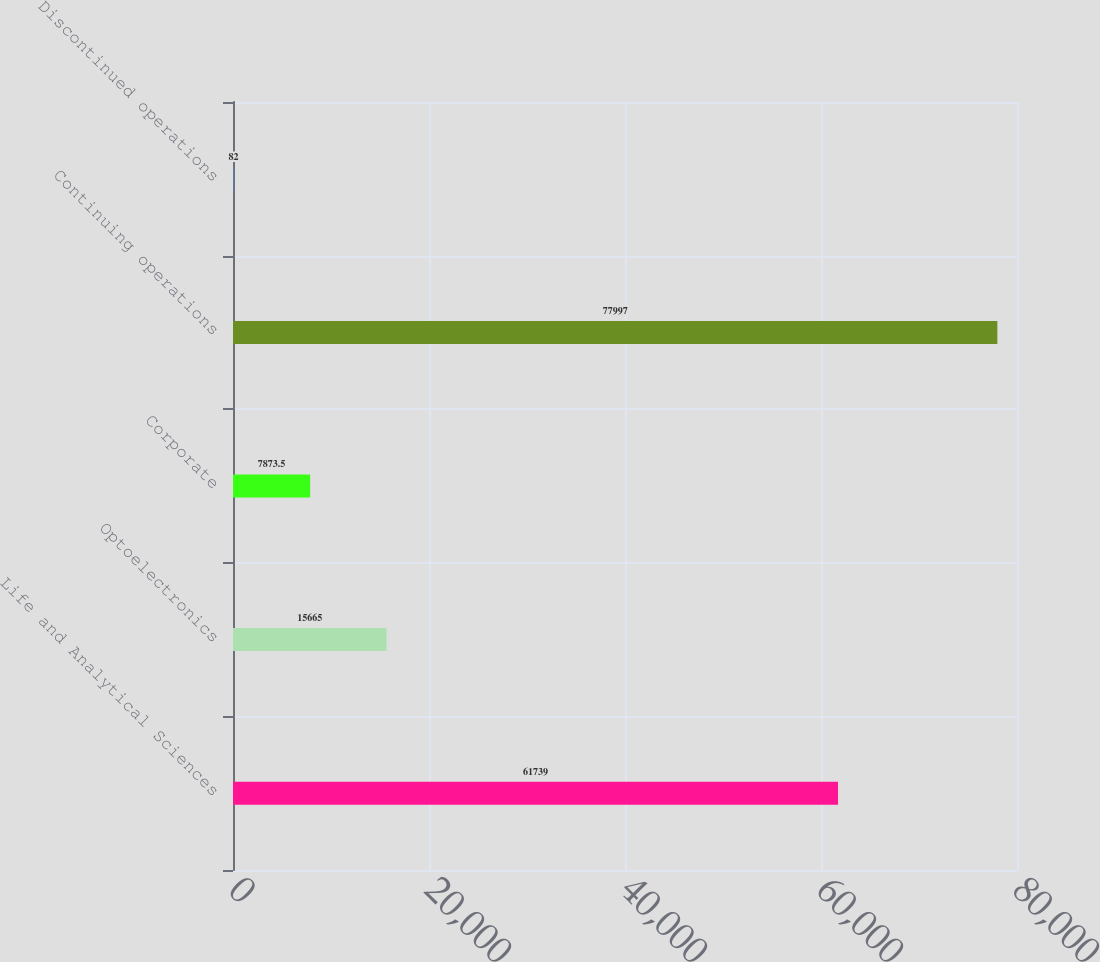Convert chart. <chart><loc_0><loc_0><loc_500><loc_500><bar_chart><fcel>Life and Analytical Sciences<fcel>Optoelectronics<fcel>Corporate<fcel>Continuing operations<fcel>Discontinued operations<nl><fcel>61739<fcel>15665<fcel>7873.5<fcel>77997<fcel>82<nl></chart> 